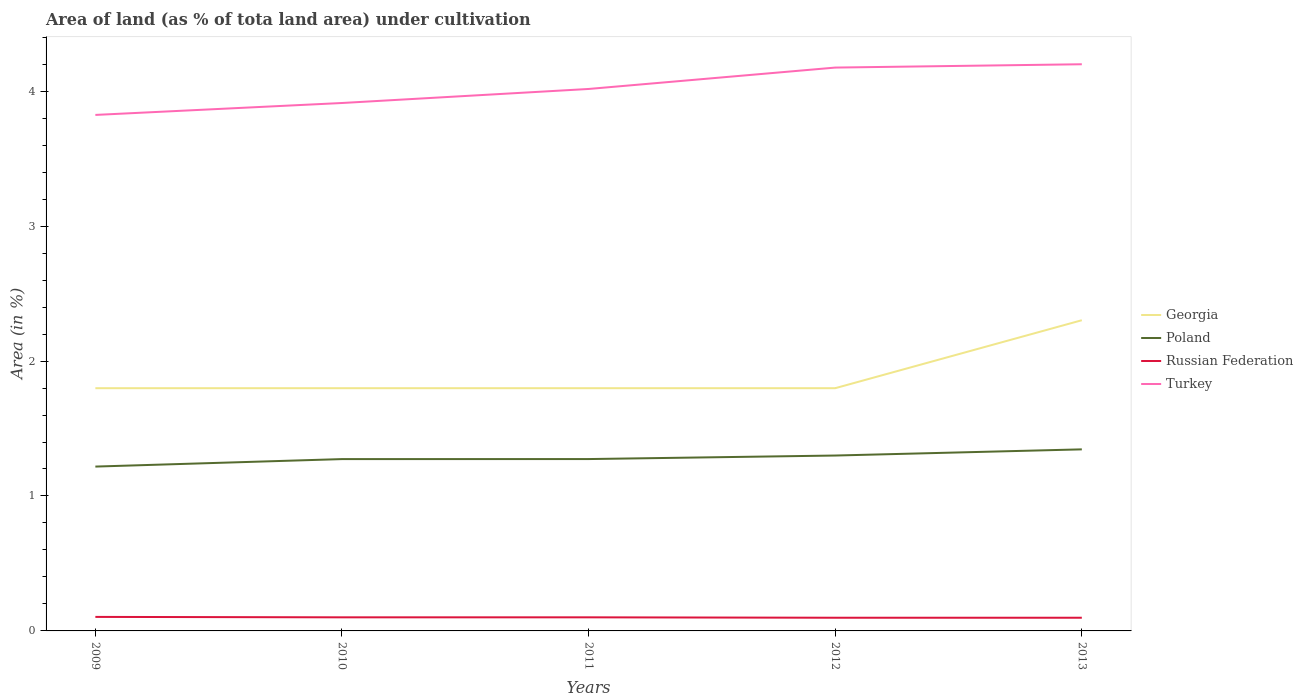How many different coloured lines are there?
Your answer should be very brief. 4. Is the number of lines equal to the number of legend labels?
Your answer should be compact. Yes. Across all years, what is the maximum percentage of land under cultivation in Turkey?
Provide a succinct answer. 3.82. In which year was the percentage of land under cultivation in Poland maximum?
Ensure brevity in your answer.  2009. What is the difference between the highest and the second highest percentage of land under cultivation in Poland?
Provide a succinct answer. 0.13. What is the difference between the highest and the lowest percentage of land under cultivation in Georgia?
Your response must be concise. 1. Is the percentage of land under cultivation in Poland strictly greater than the percentage of land under cultivation in Turkey over the years?
Offer a very short reply. Yes. How many years are there in the graph?
Make the answer very short. 5. Does the graph contain grids?
Your answer should be very brief. No. How many legend labels are there?
Your response must be concise. 4. How are the legend labels stacked?
Your response must be concise. Vertical. What is the title of the graph?
Make the answer very short. Area of land (as % of tota land area) under cultivation. What is the label or title of the Y-axis?
Your answer should be very brief. Area (in %). What is the Area (in %) in Georgia in 2009?
Provide a succinct answer. 1.8. What is the Area (in %) of Poland in 2009?
Keep it short and to the point. 1.22. What is the Area (in %) of Russian Federation in 2009?
Your answer should be very brief. 0.1. What is the Area (in %) in Turkey in 2009?
Ensure brevity in your answer.  3.82. What is the Area (in %) in Georgia in 2010?
Offer a terse response. 1.8. What is the Area (in %) of Poland in 2010?
Your answer should be very brief. 1.27. What is the Area (in %) in Russian Federation in 2010?
Offer a terse response. 0.1. What is the Area (in %) in Turkey in 2010?
Provide a short and direct response. 3.91. What is the Area (in %) of Georgia in 2011?
Your response must be concise. 1.8. What is the Area (in %) of Poland in 2011?
Your answer should be very brief. 1.27. What is the Area (in %) in Russian Federation in 2011?
Keep it short and to the point. 0.1. What is the Area (in %) in Turkey in 2011?
Offer a terse response. 4.02. What is the Area (in %) in Georgia in 2012?
Your answer should be very brief. 1.8. What is the Area (in %) in Poland in 2012?
Ensure brevity in your answer.  1.3. What is the Area (in %) of Russian Federation in 2012?
Provide a short and direct response. 0.1. What is the Area (in %) in Turkey in 2012?
Make the answer very short. 4.17. What is the Area (in %) of Georgia in 2013?
Provide a short and direct response. 2.3. What is the Area (in %) in Poland in 2013?
Ensure brevity in your answer.  1.35. What is the Area (in %) in Russian Federation in 2013?
Ensure brevity in your answer.  0.1. What is the Area (in %) of Turkey in 2013?
Your answer should be compact. 4.2. Across all years, what is the maximum Area (in %) of Georgia?
Keep it short and to the point. 2.3. Across all years, what is the maximum Area (in %) of Poland?
Make the answer very short. 1.35. Across all years, what is the maximum Area (in %) of Russian Federation?
Offer a terse response. 0.1. Across all years, what is the maximum Area (in %) of Turkey?
Offer a terse response. 4.2. Across all years, what is the minimum Area (in %) of Georgia?
Provide a short and direct response. 1.8. Across all years, what is the minimum Area (in %) of Poland?
Offer a very short reply. 1.22. Across all years, what is the minimum Area (in %) in Russian Federation?
Offer a terse response. 0.1. Across all years, what is the minimum Area (in %) of Turkey?
Your answer should be compact. 3.82. What is the total Area (in %) of Georgia in the graph?
Provide a short and direct response. 9.5. What is the total Area (in %) in Poland in the graph?
Keep it short and to the point. 6.41. What is the total Area (in %) in Russian Federation in the graph?
Give a very brief answer. 0.5. What is the total Area (in %) of Turkey in the graph?
Your answer should be very brief. 20.13. What is the difference between the Area (in %) of Georgia in 2009 and that in 2010?
Ensure brevity in your answer.  0. What is the difference between the Area (in %) of Poland in 2009 and that in 2010?
Your answer should be very brief. -0.06. What is the difference between the Area (in %) in Russian Federation in 2009 and that in 2010?
Give a very brief answer. 0. What is the difference between the Area (in %) of Turkey in 2009 and that in 2010?
Provide a short and direct response. -0.09. What is the difference between the Area (in %) in Georgia in 2009 and that in 2011?
Provide a short and direct response. 0. What is the difference between the Area (in %) in Poland in 2009 and that in 2011?
Offer a very short reply. -0.06. What is the difference between the Area (in %) in Russian Federation in 2009 and that in 2011?
Keep it short and to the point. 0. What is the difference between the Area (in %) of Turkey in 2009 and that in 2011?
Give a very brief answer. -0.19. What is the difference between the Area (in %) in Poland in 2009 and that in 2012?
Make the answer very short. -0.08. What is the difference between the Area (in %) of Russian Federation in 2009 and that in 2012?
Ensure brevity in your answer.  0.01. What is the difference between the Area (in %) of Turkey in 2009 and that in 2012?
Ensure brevity in your answer.  -0.35. What is the difference between the Area (in %) of Georgia in 2009 and that in 2013?
Keep it short and to the point. -0.5. What is the difference between the Area (in %) in Poland in 2009 and that in 2013?
Provide a succinct answer. -0.13. What is the difference between the Area (in %) in Russian Federation in 2009 and that in 2013?
Make the answer very short. 0.01. What is the difference between the Area (in %) of Turkey in 2009 and that in 2013?
Keep it short and to the point. -0.38. What is the difference between the Area (in %) in Poland in 2010 and that in 2011?
Your answer should be compact. -0. What is the difference between the Area (in %) in Turkey in 2010 and that in 2011?
Your answer should be very brief. -0.1. What is the difference between the Area (in %) of Georgia in 2010 and that in 2012?
Offer a terse response. 0. What is the difference between the Area (in %) of Poland in 2010 and that in 2012?
Your answer should be compact. -0.03. What is the difference between the Area (in %) of Russian Federation in 2010 and that in 2012?
Provide a succinct answer. 0. What is the difference between the Area (in %) in Turkey in 2010 and that in 2012?
Keep it short and to the point. -0.26. What is the difference between the Area (in %) of Georgia in 2010 and that in 2013?
Offer a terse response. -0.5. What is the difference between the Area (in %) of Poland in 2010 and that in 2013?
Provide a short and direct response. -0.07. What is the difference between the Area (in %) of Russian Federation in 2010 and that in 2013?
Give a very brief answer. 0. What is the difference between the Area (in %) of Turkey in 2010 and that in 2013?
Provide a short and direct response. -0.29. What is the difference between the Area (in %) of Georgia in 2011 and that in 2012?
Provide a short and direct response. 0. What is the difference between the Area (in %) of Poland in 2011 and that in 2012?
Offer a terse response. -0.03. What is the difference between the Area (in %) of Russian Federation in 2011 and that in 2012?
Keep it short and to the point. 0. What is the difference between the Area (in %) in Turkey in 2011 and that in 2012?
Offer a very short reply. -0.16. What is the difference between the Area (in %) in Georgia in 2011 and that in 2013?
Give a very brief answer. -0.5. What is the difference between the Area (in %) in Poland in 2011 and that in 2013?
Make the answer very short. -0.07. What is the difference between the Area (in %) of Russian Federation in 2011 and that in 2013?
Offer a very short reply. 0. What is the difference between the Area (in %) in Turkey in 2011 and that in 2013?
Your answer should be compact. -0.18. What is the difference between the Area (in %) in Georgia in 2012 and that in 2013?
Make the answer very short. -0.5. What is the difference between the Area (in %) of Poland in 2012 and that in 2013?
Offer a terse response. -0.05. What is the difference between the Area (in %) of Turkey in 2012 and that in 2013?
Give a very brief answer. -0.02. What is the difference between the Area (in %) of Georgia in 2009 and the Area (in %) of Poland in 2010?
Provide a succinct answer. 0.53. What is the difference between the Area (in %) in Georgia in 2009 and the Area (in %) in Russian Federation in 2010?
Make the answer very short. 1.7. What is the difference between the Area (in %) in Georgia in 2009 and the Area (in %) in Turkey in 2010?
Provide a short and direct response. -2.11. What is the difference between the Area (in %) in Poland in 2009 and the Area (in %) in Russian Federation in 2010?
Your answer should be compact. 1.12. What is the difference between the Area (in %) in Poland in 2009 and the Area (in %) in Turkey in 2010?
Make the answer very short. -2.69. What is the difference between the Area (in %) of Russian Federation in 2009 and the Area (in %) of Turkey in 2010?
Provide a short and direct response. -3.81. What is the difference between the Area (in %) in Georgia in 2009 and the Area (in %) in Poland in 2011?
Offer a terse response. 0.53. What is the difference between the Area (in %) in Georgia in 2009 and the Area (in %) in Russian Federation in 2011?
Your answer should be compact. 1.7. What is the difference between the Area (in %) in Georgia in 2009 and the Area (in %) in Turkey in 2011?
Give a very brief answer. -2.22. What is the difference between the Area (in %) of Poland in 2009 and the Area (in %) of Russian Federation in 2011?
Your answer should be very brief. 1.12. What is the difference between the Area (in %) in Poland in 2009 and the Area (in %) in Turkey in 2011?
Your answer should be very brief. -2.8. What is the difference between the Area (in %) of Russian Federation in 2009 and the Area (in %) of Turkey in 2011?
Provide a succinct answer. -3.91. What is the difference between the Area (in %) in Georgia in 2009 and the Area (in %) in Poland in 2012?
Provide a short and direct response. 0.5. What is the difference between the Area (in %) of Georgia in 2009 and the Area (in %) of Russian Federation in 2012?
Ensure brevity in your answer.  1.7. What is the difference between the Area (in %) in Georgia in 2009 and the Area (in %) in Turkey in 2012?
Your answer should be very brief. -2.38. What is the difference between the Area (in %) of Poland in 2009 and the Area (in %) of Russian Federation in 2012?
Offer a terse response. 1.12. What is the difference between the Area (in %) in Poland in 2009 and the Area (in %) in Turkey in 2012?
Keep it short and to the point. -2.96. What is the difference between the Area (in %) in Russian Federation in 2009 and the Area (in %) in Turkey in 2012?
Provide a succinct answer. -4.07. What is the difference between the Area (in %) of Georgia in 2009 and the Area (in %) of Poland in 2013?
Offer a very short reply. 0.45. What is the difference between the Area (in %) in Georgia in 2009 and the Area (in %) in Russian Federation in 2013?
Keep it short and to the point. 1.7. What is the difference between the Area (in %) of Georgia in 2009 and the Area (in %) of Turkey in 2013?
Provide a short and direct response. -2.4. What is the difference between the Area (in %) in Poland in 2009 and the Area (in %) in Russian Federation in 2013?
Give a very brief answer. 1.12. What is the difference between the Area (in %) of Poland in 2009 and the Area (in %) of Turkey in 2013?
Offer a terse response. -2.98. What is the difference between the Area (in %) of Russian Federation in 2009 and the Area (in %) of Turkey in 2013?
Keep it short and to the point. -4.1. What is the difference between the Area (in %) in Georgia in 2010 and the Area (in %) in Poland in 2011?
Your response must be concise. 0.53. What is the difference between the Area (in %) of Georgia in 2010 and the Area (in %) of Russian Federation in 2011?
Make the answer very short. 1.7. What is the difference between the Area (in %) of Georgia in 2010 and the Area (in %) of Turkey in 2011?
Give a very brief answer. -2.22. What is the difference between the Area (in %) in Poland in 2010 and the Area (in %) in Russian Federation in 2011?
Offer a terse response. 1.17. What is the difference between the Area (in %) in Poland in 2010 and the Area (in %) in Turkey in 2011?
Offer a terse response. -2.74. What is the difference between the Area (in %) in Russian Federation in 2010 and the Area (in %) in Turkey in 2011?
Provide a succinct answer. -3.92. What is the difference between the Area (in %) in Georgia in 2010 and the Area (in %) in Poland in 2012?
Provide a succinct answer. 0.5. What is the difference between the Area (in %) in Georgia in 2010 and the Area (in %) in Russian Federation in 2012?
Keep it short and to the point. 1.7. What is the difference between the Area (in %) of Georgia in 2010 and the Area (in %) of Turkey in 2012?
Make the answer very short. -2.38. What is the difference between the Area (in %) in Poland in 2010 and the Area (in %) in Russian Federation in 2012?
Offer a terse response. 1.18. What is the difference between the Area (in %) in Poland in 2010 and the Area (in %) in Turkey in 2012?
Offer a very short reply. -2.9. What is the difference between the Area (in %) of Russian Federation in 2010 and the Area (in %) of Turkey in 2012?
Provide a succinct answer. -4.07. What is the difference between the Area (in %) in Georgia in 2010 and the Area (in %) in Poland in 2013?
Ensure brevity in your answer.  0.45. What is the difference between the Area (in %) of Georgia in 2010 and the Area (in %) of Russian Federation in 2013?
Offer a very short reply. 1.7. What is the difference between the Area (in %) of Georgia in 2010 and the Area (in %) of Turkey in 2013?
Offer a terse response. -2.4. What is the difference between the Area (in %) in Poland in 2010 and the Area (in %) in Russian Federation in 2013?
Offer a terse response. 1.18. What is the difference between the Area (in %) in Poland in 2010 and the Area (in %) in Turkey in 2013?
Your response must be concise. -2.93. What is the difference between the Area (in %) of Russian Federation in 2010 and the Area (in %) of Turkey in 2013?
Your answer should be very brief. -4.1. What is the difference between the Area (in %) in Georgia in 2011 and the Area (in %) in Poland in 2012?
Keep it short and to the point. 0.5. What is the difference between the Area (in %) in Georgia in 2011 and the Area (in %) in Russian Federation in 2012?
Make the answer very short. 1.7. What is the difference between the Area (in %) of Georgia in 2011 and the Area (in %) of Turkey in 2012?
Keep it short and to the point. -2.38. What is the difference between the Area (in %) of Poland in 2011 and the Area (in %) of Russian Federation in 2012?
Your response must be concise. 1.18. What is the difference between the Area (in %) in Poland in 2011 and the Area (in %) in Turkey in 2012?
Offer a very short reply. -2.9. What is the difference between the Area (in %) of Russian Federation in 2011 and the Area (in %) of Turkey in 2012?
Your response must be concise. -4.07. What is the difference between the Area (in %) in Georgia in 2011 and the Area (in %) in Poland in 2013?
Provide a short and direct response. 0.45. What is the difference between the Area (in %) in Georgia in 2011 and the Area (in %) in Russian Federation in 2013?
Your response must be concise. 1.7. What is the difference between the Area (in %) in Georgia in 2011 and the Area (in %) in Turkey in 2013?
Keep it short and to the point. -2.4. What is the difference between the Area (in %) in Poland in 2011 and the Area (in %) in Russian Federation in 2013?
Offer a very short reply. 1.18. What is the difference between the Area (in %) of Poland in 2011 and the Area (in %) of Turkey in 2013?
Ensure brevity in your answer.  -2.93. What is the difference between the Area (in %) of Russian Federation in 2011 and the Area (in %) of Turkey in 2013?
Ensure brevity in your answer.  -4.1. What is the difference between the Area (in %) of Georgia in 2012 and the Area (in %) of Poland in 2013?
Your answer should be compact. 0.45. What is the difference between the Area (in %) in Georgia in 2012 and the Area (in %) in Russian Federation in 2013?
Your response must be concise. 1.7. What is the difference between the Area (in %) of Georgia in 2012 and the Area (in %) of Turkey in 2013?
Provide a short and direct response. -2.4. What is the difference between the Area (in %) of Poland in 2012 and the Area (in %) of Russian Federation in 2013?
Keep it short and to the point. 1.2. What is the difference between the Area (in %) of Poland in 2012 and the Area (in %) of Turkey in 2013?
Your answer should be compact. -2.9. What is the difference between the Area (in %) in Russian Federation in 2012 and the Area (in %) in Turkey in 2013?
Give a very brief answer. -4.1. What is the average Area (in %) in Georgia per year?
Offer a terse response. 1.9. What is the average Area (in %) of Poland per year?
Provide a short and direct response. 1.28. What is the average Area (in %) in Russian Federation per year?
Offer a terse response. 0.1. What is the average Area (in %) of Turkey per year?
Provide a succinct answer. 4.03. In the year 2009, what is the difference between the Area (in %) of Georgia and Area (in %) of Poland?
Your answer should be compact. 0.58. In the year 2009, what is the difference between the Area (in %) of Georgia and Area (in %) of Russian Federation?
Your answer should be compact. 1.7. In the year 2009, what is the difference between the Area (in %) of Georgia and Area (in %) of Turkey?
Give a very brief answer. -2.03. In the year 2009, what is the difference between the Area (in %) of Poland and Area (in %) of Russian Federation?
Provide a succinct answer. 1.11. In the year 2009, what is the difference between the Area (in %) in Poland and Area (in %) in Turkey?
Give a very brief answer. -2.61. In the year 2009, what is the difference between the Area (in %) of Russian Federation and Area (in %) of Turkey?
Your answer should be very brief. -3.72. In the year 2010, what is the difference between the Area (in %) in Georgia and Area (in %) in Poland?
Provide a succinct answer. 0.53. In the year 2010, what is the difference between the Area (in %) in Georgia and Area (in %) in Russian Federation?
Keep it short and to the point. 1.7. In the year 2010, what is the difference between the Area (in %) of Georgia and Area (in %) of Turkey?
Provide a succinct answer. -2.11. In the year 2010, what is the difference between the Area (in %) of Poland and Area (in %) of Russian Federation?
Your response must be concise. 1.17. In the year 2010, what is the difference between the Area (in %) of Poland and Area (in %) of Turkey?
Ensure brevity in your answer.  -2.64. In the year 2010, what is the difference between the Area (in %) of Russian Federation and Area (in %) of Turkey?
Offer a terse response. -3.81. In the year 2011, what is the difference between the Area (in %) in Georgia and Area (in %) in Poland?
Provide a short and direct response. 0.53. In the year 2011, what is the difference between the Area (in %) in Georgia and Area (in %) in Russian Federation?
Your answer should be compact. 1.7. In the year 2011, what is the difference between the Area (in %) of Georgia and Area (in %) of Turkey?
Offer a terse response. -2.22. In the year 2011, what is the difference between the Area (in %) of Poland and Area (in %) of Russian Federation?
Your answer should be very brief. 1.17. In the year 2011, what is the difference between the Area (in %) of Poland and Area (in %) of Turkey?
Your response must be concise. -2.74. In the year 2011, what is the difference between the Area (in %) in Russian Federation and Area (in %) in Turkey?
Provide a short and direct response. -3.92. In the year 2012, what is the difference between the Area (in %) of Georgia and Area (in %) of Poland?
Your response must be concise. 0.5. In the year 2012, what is the difference between the Area (in %) in Georgia and Area (in %) in Russian Federation?
Give a very brief answer. 1.7. In the year 2012, what is the difference between the Area (in %) in Georgia and Area (in %) in Turkey?
Your answer should be very brief. -2.38. In the year 2012, what is the difference between the Area (in %) of Poland and Area (in %) of Russian Federation?
Give a very brief answer. 1.2. In the year 2012, what is the difference between the Area (in %) of Poland and Area (in %) of Turkey?
Offer a terse response. -2.88. In the year 2012, what is the difference between the Area (in %) in Russian Federation and Area (in %) in Turkey?
Your answer should be compact. -4.08. In the year 2013, what is the difference between the Area (in %) in Georgia and Area (in %) in Poland?
Ensure brevity in your answer.  0.96. In the year 2013, what is the difference between the Area (in %) of Georgia and Area (in %) of Russian Federation?
Offer a very short reply. 2.2. In the year 2013, what is the difference between the Area (in %) of Georgia and Area (in %) of Turkey?
Offer a terse response. -1.9. In the year 2013, what is the difference between the Area (in %) in Poland and Area (in %) in Russian Federation?
Your response must be concise. 1.25. In the year 2013, what is the difference between the Area (in %) of Poland and Area (in %) of Turkey?
Your answer should be very brief. -2.85. In the year 2013, what is the difference between the Area (in %) of Russian Federation and Area (in %) of Turkey?
Your answer should be compact. -4.1. What is the ratio of the Area (in %) of Georgia in 2009 to that in 2010?
Ensure brevity in your answer.  1. What is the ratio of the Area (in %) of Poland in 2009 to that in 2010?
Provide a short and direct response. 0.96. What is the ratio of the Area (in %) of Russian Federation in 2009 to that in 2010?
Your answer should be compact. 1.03. What is the ratio of the Area (in %) in Turkey in 2009 to that in 2010?
Keep it short and to the point. 0.98. What is the ratio of the Area (in %) in Poland in 2009 to that in 2011?
Ensure brevity in your answer.  0.96. What is the ratio of the Area (in %) in Russian Federation in 2009 to that in 2011?
Give a very brief answer. 1.03. What is the ratio of the Area (in %) in Turkey in 2009 to that in 2011?
Offer a terse response. 0.95. What is the ratio of the Area (in %) of Poland in 2009 to that in 2012?
Offer a terse response. 0.94. What is the ratio of the Area (in %) in Turkey in 2009 to that in 2012?
Give a very brief answer. 0.92. What is the ratio of the Area (in %) of Georgia in 2009 to that in 2013?
Give a very brief answer. 0.78. What is the ratio of the Area (in %) of Poland in 2009 to that in 2013?
Make the answer very short. 0.91. What is the ratio of the Area (in %) of Russian Federation in 2009 to that in 2013?
Your response must be concise. 1.06. What is the ratio of the Area (in %) in Turkey in 2009 to that in 2013?
Make the answer very short. 0.91. What is the ratio of the Area (in %) of Georgia in 2010 to that in 2011?
Provide a short and direct response. 1. What is the ratio of the Area (in %) of Poland in 2010 to that in 2011?
Give a very brief answer. 1. What is the ratio of the Area (in %) of Russian Federation in 2010 to that in 2011?
Your response must be concise. 1. What is the ratio of the Area (in %) of Turkey in 2010 to that in 2011?
Offer a terse response. 0.97. What is the ratio of the Area (in %) of Georgia in 2010 to that in 2012?
Your answer should be compact. 1. What is the ratio of the Area (in %) of Poland in 2010 to that in 2012?
Your response must be concise. 0.98. What is the ratio of the Area (in %) in Russian Federation in 2010 to that in 2012?
Keep it short and to the point. 1.03. What is the ratio of the Area (in %) in Turkey in 2010 to that in 2012?
Your answer should be compact. 0.94. What is the ratio of the Area (in %) in Georgia in 2010 to that in 2013?
Make the answer very short. 0.78. What is the ratio of the Area (in %) in Poland in 2010 to that in 2013?
Your answer should be compact. 0.95. What is the ratio of the Area (in %) in Russian Federation in 2010 to that in 2013?
Your response must be concise. 1.03. What is the ratio of the Area (in %) of Turkey in 2010 to that in 2013?
Offer a terse response. 0.93. What is the ratio of the Area (in %) in Georgia in 2011 to that in 2012?
Ensure brevity in your answer.  1. What is the ratio of the Area (in %) in Poland in 2011 to that in 2012?
Offer a terse response. 0.98. What is the ratio of the Area (in %) in Russian Federation in 2011 to that in 2012?
Offer a very short reply. 1.03. What is the ratio of the Area (in %) of Turkey in 2011 to that in 2012?
Provide a succinct answer. 0.96. What is the ratio of the Area (in %) of Georgia in 2011 to that in 2013?
Make the answer very short. 0.78. What is the ratio of the Area (in %) of Poland in 2011 to that in 2013?
Provide a succinct answer. 0.95. What is the ratio of the Area (in %) in Russian Federation in 2011 to that in 2013?
Your answer should be very brief. 1.03. What is the ratio of the Area (in %) in Turkey in 2011 to that in 2013?
Make the answer very short. 0.96. What is the ratio of the Area (in %) of Georgia in 2012 to that in 2013?
Make the answer very short. 0.78. What is the difference between the highest and the second highest Area (in %) of Georgia?
Make the answer very short. 0.5. What is the difference between the highest and the second highest Area (in %) of Poland?
Your answer should be very brief. 0.05. What is the difference between the highest and the second highest Area (in %) in Russian Federation?
Provide a short and direct response. 0. What is the difference between the highest and the second highest Area (in %) of Turkey?
Your answer should be very brief. 0.02. What is the difference between the highest and the lowest Area (in %) in Georgia?
Your answer should be very brief. 0.5. What is the difference between the highest and the lowest Area (in %) in Poland?
Your response must be concise. 0.13. What is the difference between the highest and the lowest Area (in %) of Russian Federation?
Provide a short and direct response. 0.01. What is the difference between the highest and the lowest Area (in %) of Turkey?
Provide a succinct answer. 0.38. 